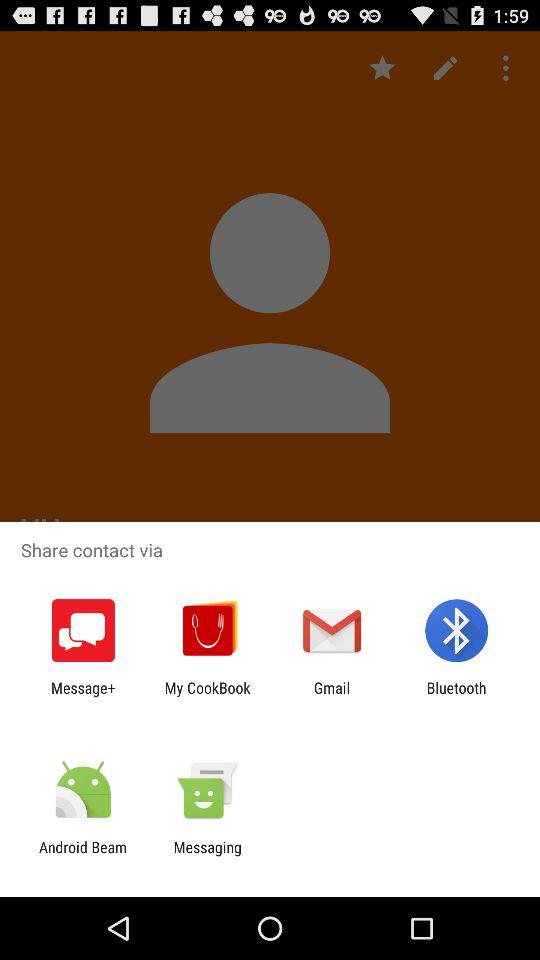Who is the contact?
When the provided information is insufficient, respond with <no answer>. <no answer> 